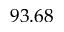<formula> <loc_0><loc_0><loc_500><loc_500>9 3 . 6 8</formula> 